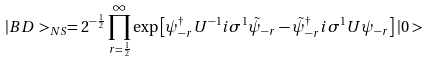<formula> <loc_0><loc_0><loc_500><loc_500>| B D > _ { N S } = 2 ^ { - \frac { 1 } { 2 } } \prod _ { r = \frac { 1 } { 2 } } ^ { \infty } \exp \left [ \psi _ { - r } ^ { \dagger } U ^ { - 1 } i \sigma ^ { 1 } \tilde { \psi } _ { - r } - \tilde { \psi } ^ { \dagger } _ { - r } i \sigma ^ { 1 } U \psi _ { - r } \right ] | 0 ></formula> 